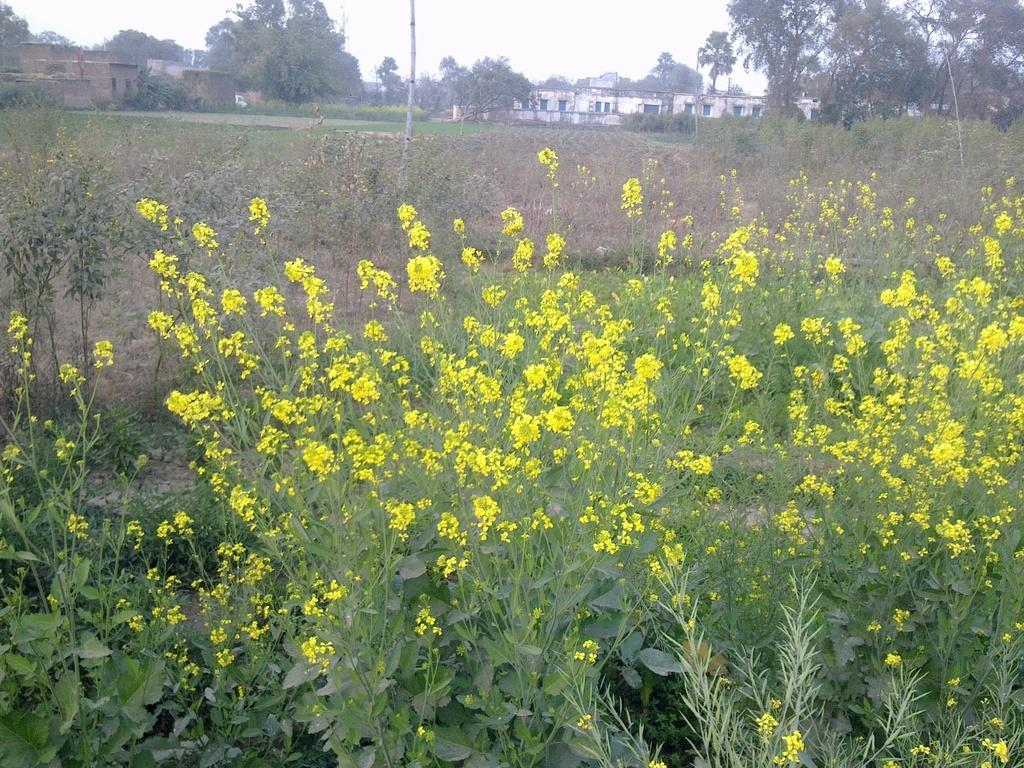What type of living organisms can be seen in the image? Plants and flowers are visible in the image. What type of structures can be seen in the image? Buildings are visible in the image. What type of vegetation is present in the image? Trees are present in the image. What is visible at the top of the image? The sky is visible at the top of the image. Can you tell me how many ladybugs are crawling on the plants in the image? There is no mention of ladybugs in the image, so it is not possible to determine how many there might be. What is the digestion process of the plants in the image? The image does not provide information about the digestion process of the plants; it only shows their visual appearance. 